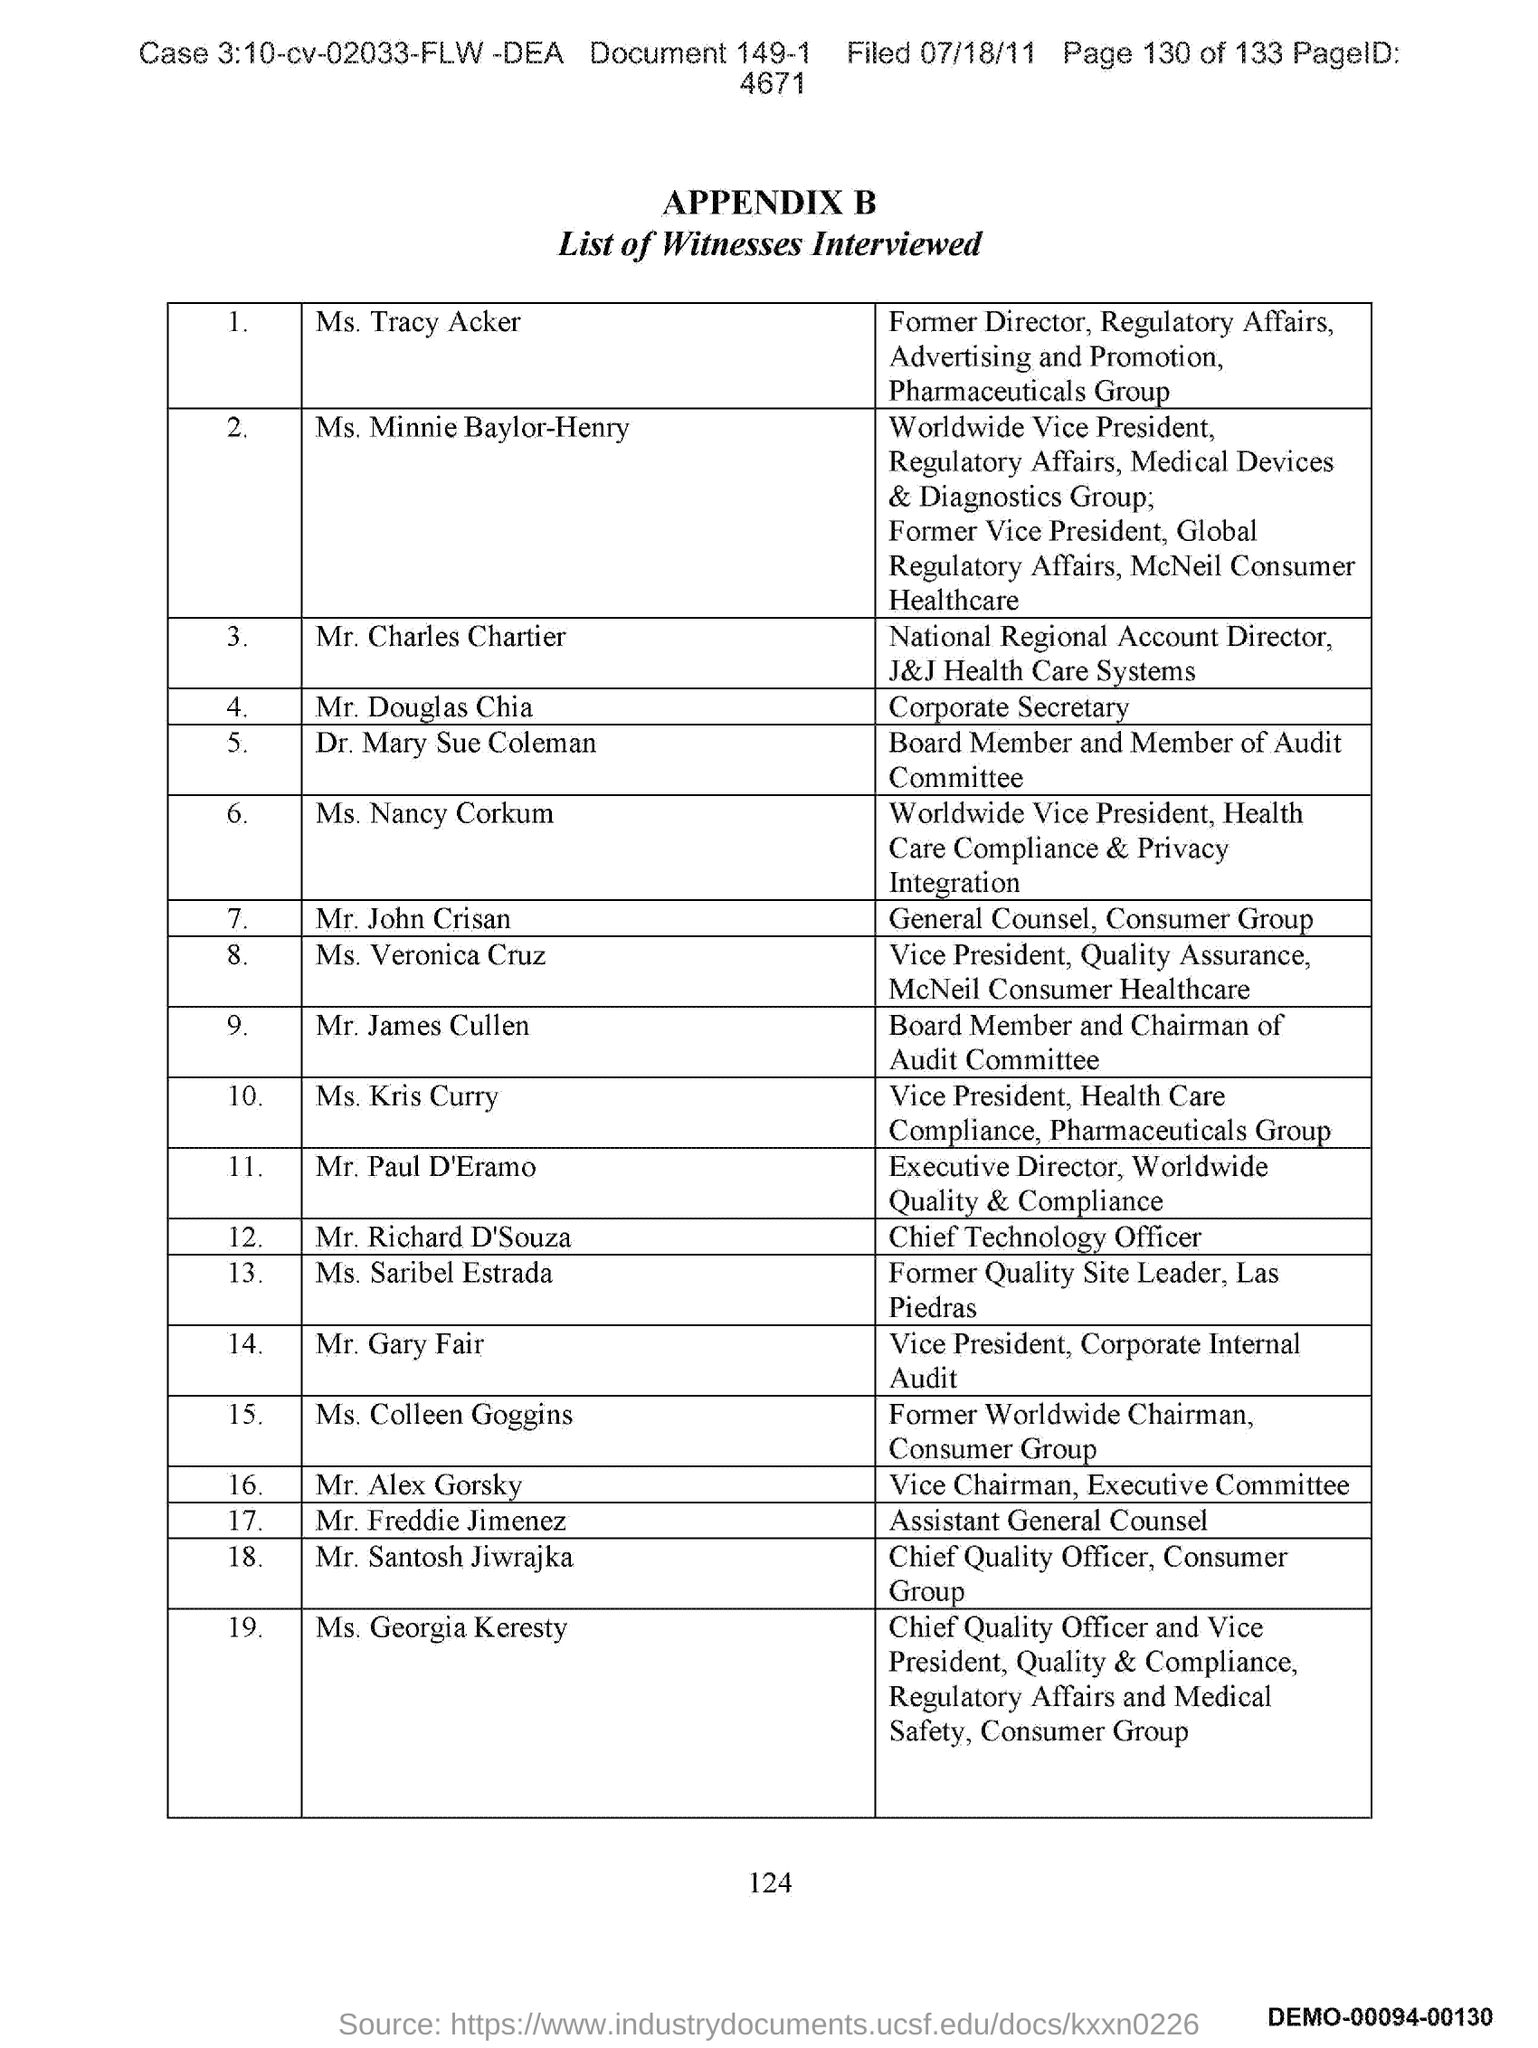Who is the Vice President of Corporate Internal Audit?
Offer a terse response. Mr. Gary Fair. Who is the Chief Quality Officer of Consumer Group?
Provide a succinct answer. Mr. Santosh Jiwrajka. Who is the Chief Technology Officer?
Offer a terse response. Mr. Richard D'Souza. Who is the General Counsel of Consumer Group?
Offer a terse response. John Crisan. Who is the Corporate Secretary?
Provide a succinct answer. Mr. Douglas Chia. 